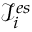Convert formula to latex. <formula><loc_0><loc_0><loc_500><loc_500>\mathcal { I } _ { i } ^ { e s }</formula> 